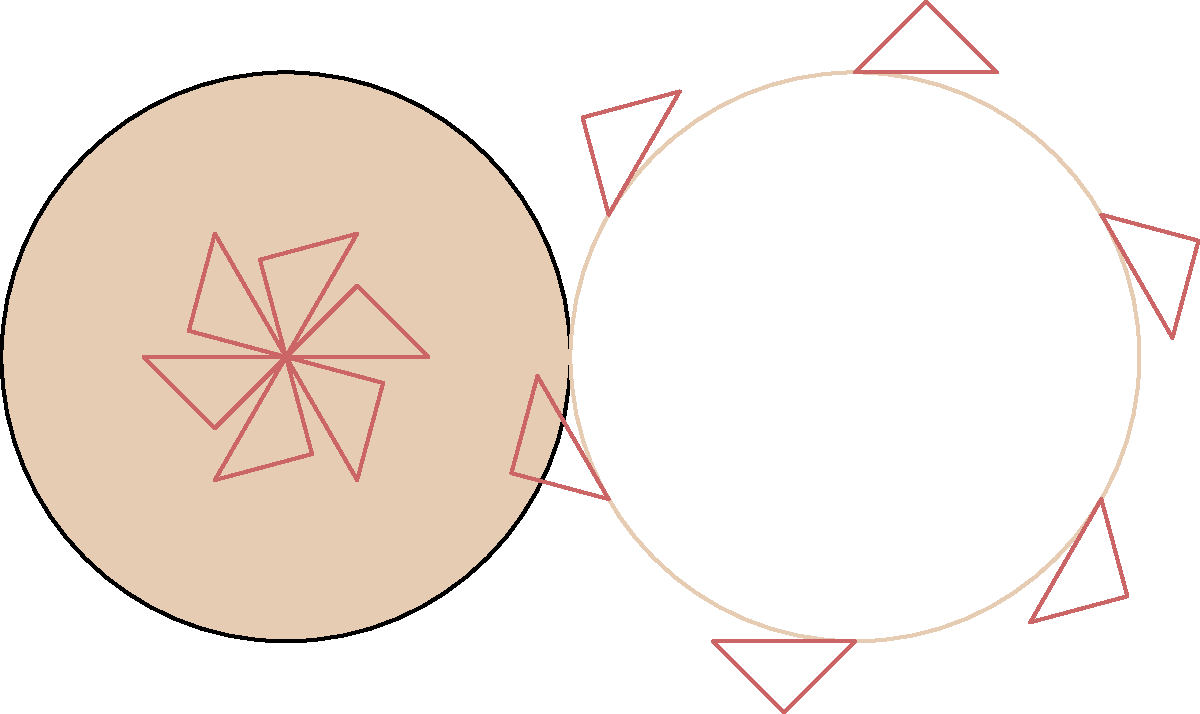You've created a new hexagonal frosting pattern for a circular cake, as shown on the left. To make the design more interesting, you want to translate the pattern outwards from the center of the cake. If each triangular segment of the pattern is translated 2 units away from the center, what will be the total area covered by the new frosting pattern compared to the original? Let's approach this step-by-step:

1) The original pattern consists of 6 equilateral triangles arranged in a hexagon.

2) When we translate each triangle 2 units away from the center, we're essentially creating a larger hexagon.

3) The area of an equilateral triangle with side length $s$ is given by:

   $A = \frac{\sqrt{3}}{4}s^2$

4) In the original pattern, if we assume the radius of the cake is 2 units, the side length of each triangle is 1 unit.

5) The area of each original triangle is:

   $A_1 = \frac{\sqrt{3}}{4} \cdot 1^2 = \frac{\sqrt{3}}{4}$

6) After translation, the triangles form a hexagon with radius 4 units. The side length of each new triangle is 2 units.

7) The area of each new triangle is:

   $A_2 = \frac{\sqrt{3}}{4} \cdot 2^2 = \sqrt{3}$

8) The ratio of the new area to the original area is:

   $\frac{A_2}{A_1} = \frac{\sqrt{3}}{\frac{\sqrt{3}}{4}} = 4$

Therefore, the new frosting pattern covers 4 times the area of the original pattern.
Answer: 4 times the original area 